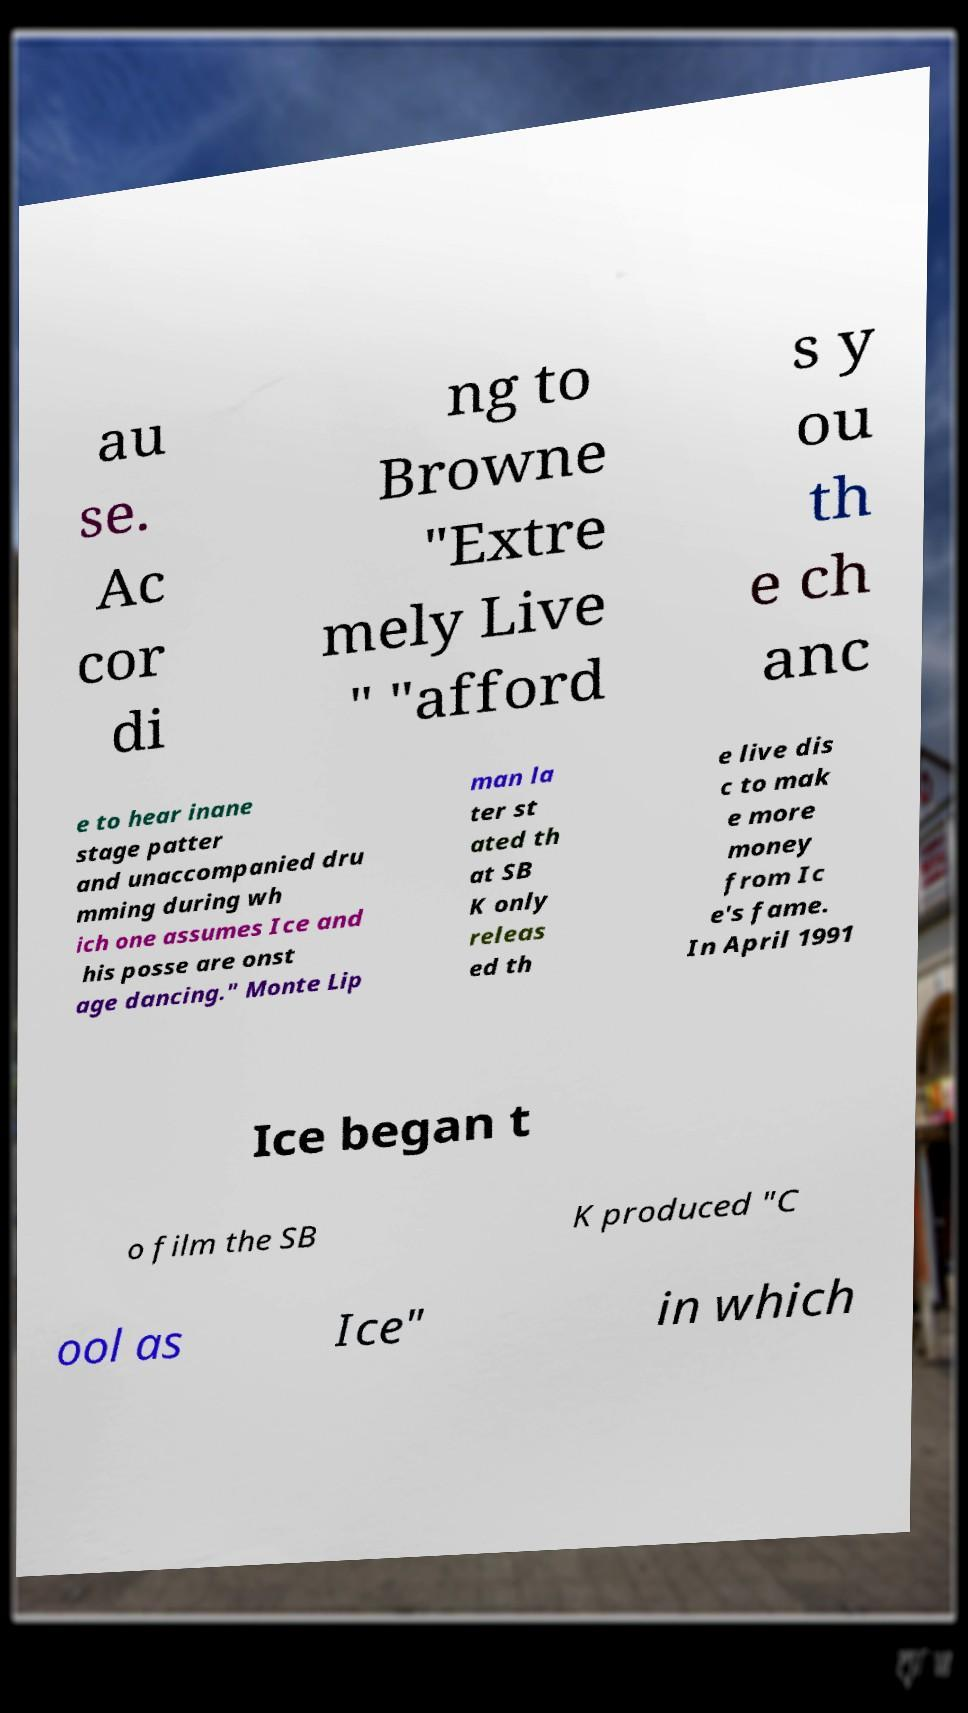Please identify and transcribe the text found in this image. au se. Ac cor di ng to Browne "Extre mely Live " "afford s y ou th e ch anc e to hear inane stage patter and unaccompanied dru mming during wh ich one assumes Ice and his posse are onst age dancing." Monte Lip man la ter st ated th at SB K only releas ed th e live dis c to mak e more money from Ic e's fame. In April 1991 Ice began t o film the SB K produced "C ool as Ice" in which 